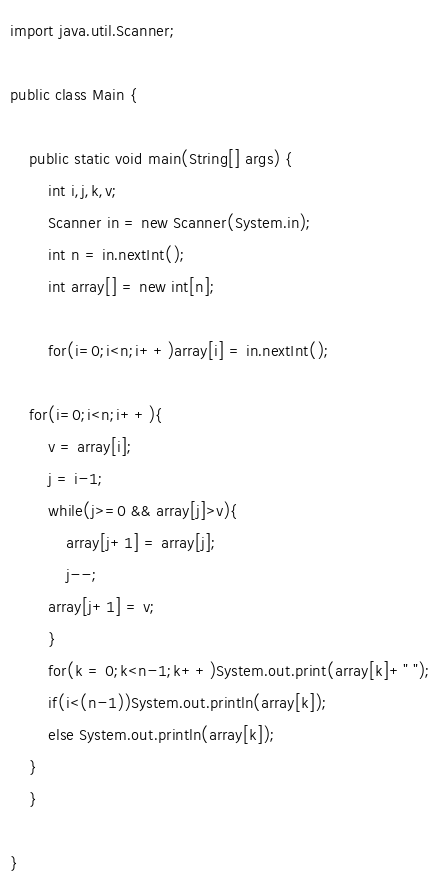<code> <loc_0><loc_0><loc_500><loc_500><_Java_>import java.util.Scanner;

public class Main {

	public static void main(String[] args) {
		int i,j,k,v;
		Scanner in = new Scanner(System.in);
		int n = in.nextInt();
		int array[] = new int[n];

		for(i=0;i<n;i++)array[i] = in.nextInt();

	for(i=0;i<n;i++){
		v = array[i];
		j = i-1;
		while(j>=0 && array[j]>v){
			array[j+1] = array[j];
			j--;
		array[j+1] = v;
		}
	    for(k = 0;k<n-1;k++)System.out.print(array[k]+" ");
	    if(i<(n-1))System.out.println(array[k]);
	    else System.out.println(array[k]);
	}
	}

}</code> 